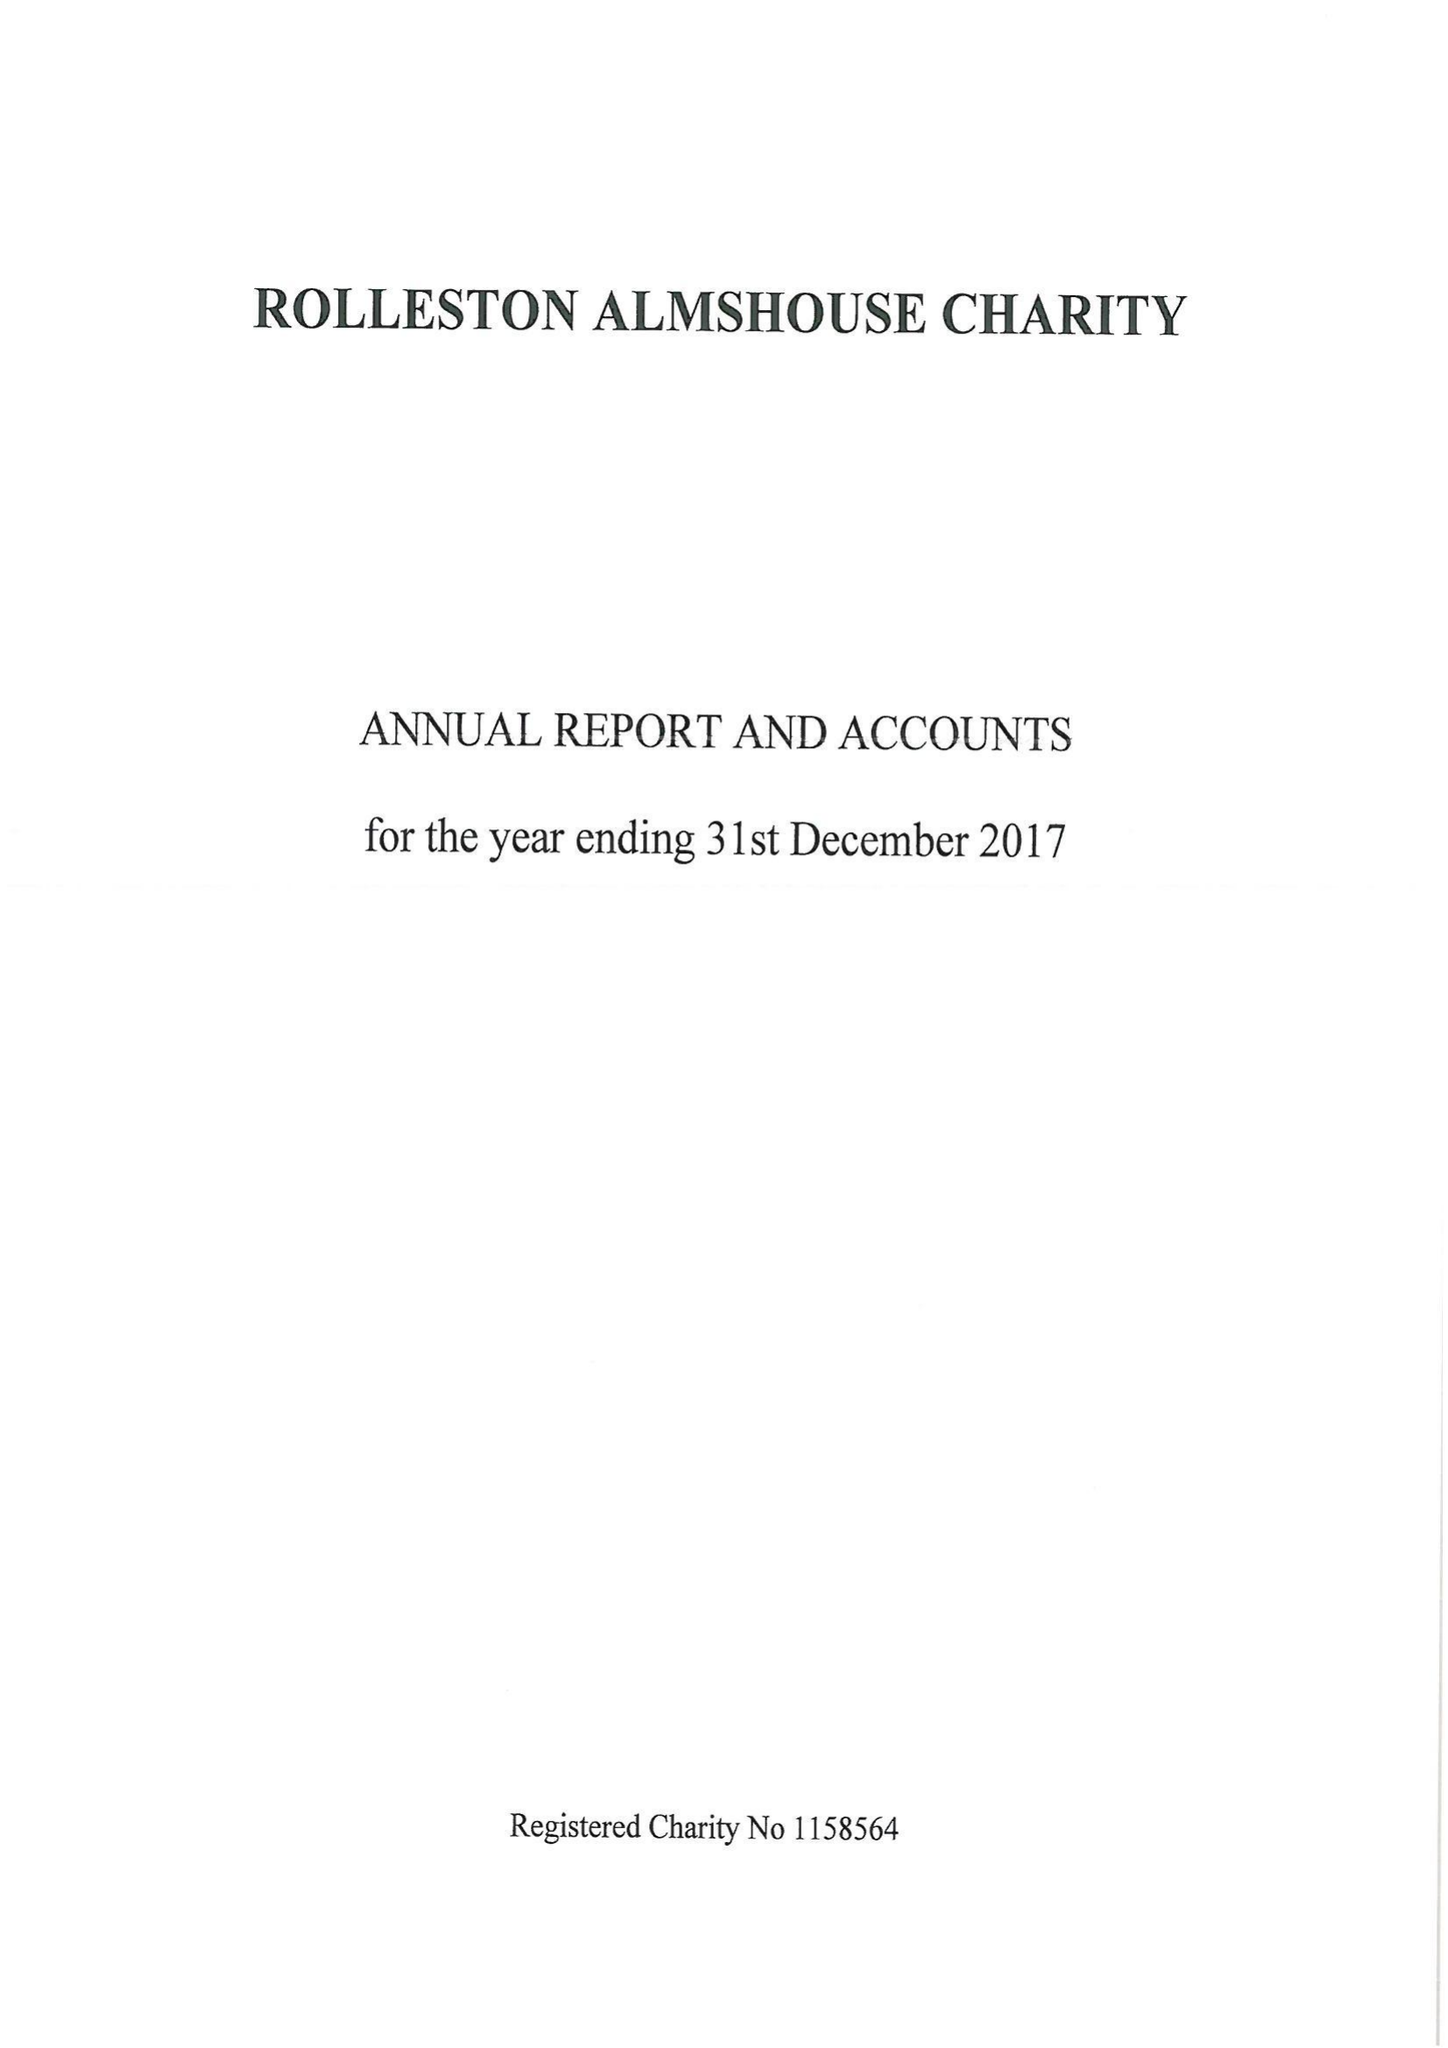What is the value for the address__post_town?
Answer the question using a single word or phrase. BURTON-ON-TRENT 